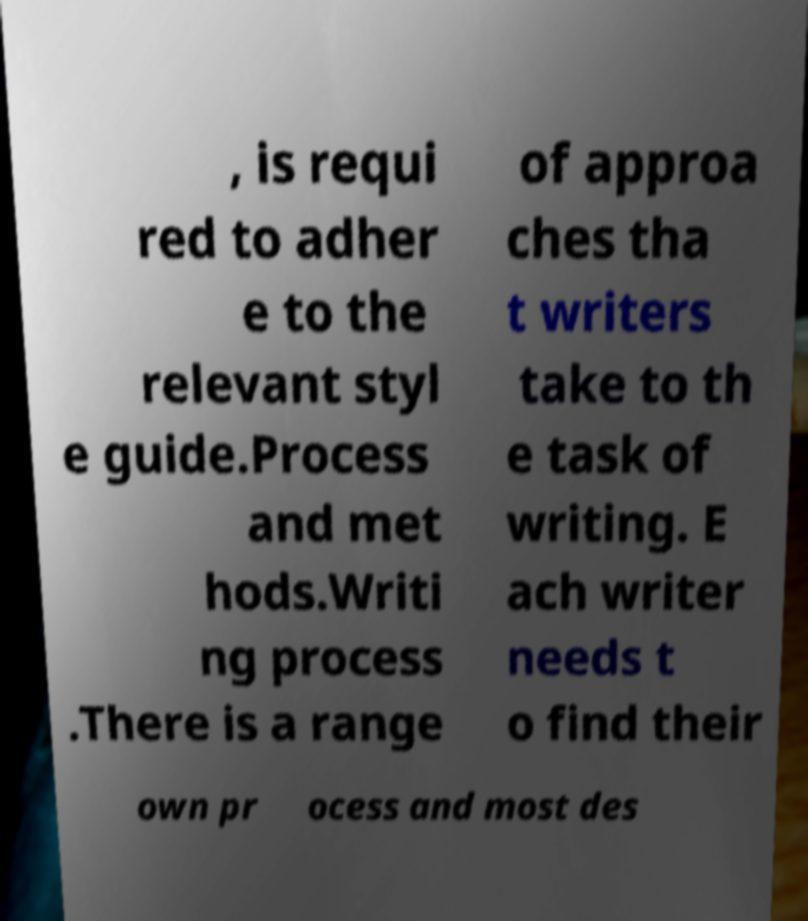Could you assist in decoding the text presented in this image and type it out clearly? , is requi red to adher e to the relevant styl e guide.Process and met hods.Writi ng process .There is a range of approa ches tha t writers take to th e task of writing. E ach writer needs t o find their own pr ocess and most des 